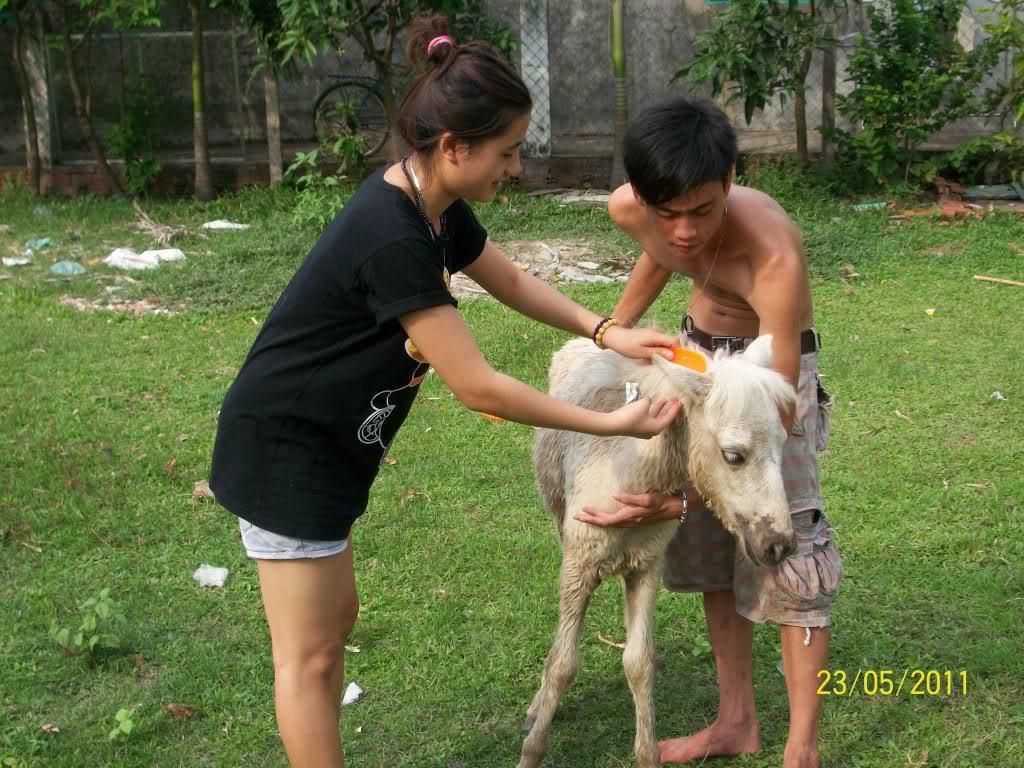Could you give a brief overview of what you see in this image? In this image there are two persons standing and holding an animal, and in the background there are plants,bicycle, grass and a watermark on the image. 